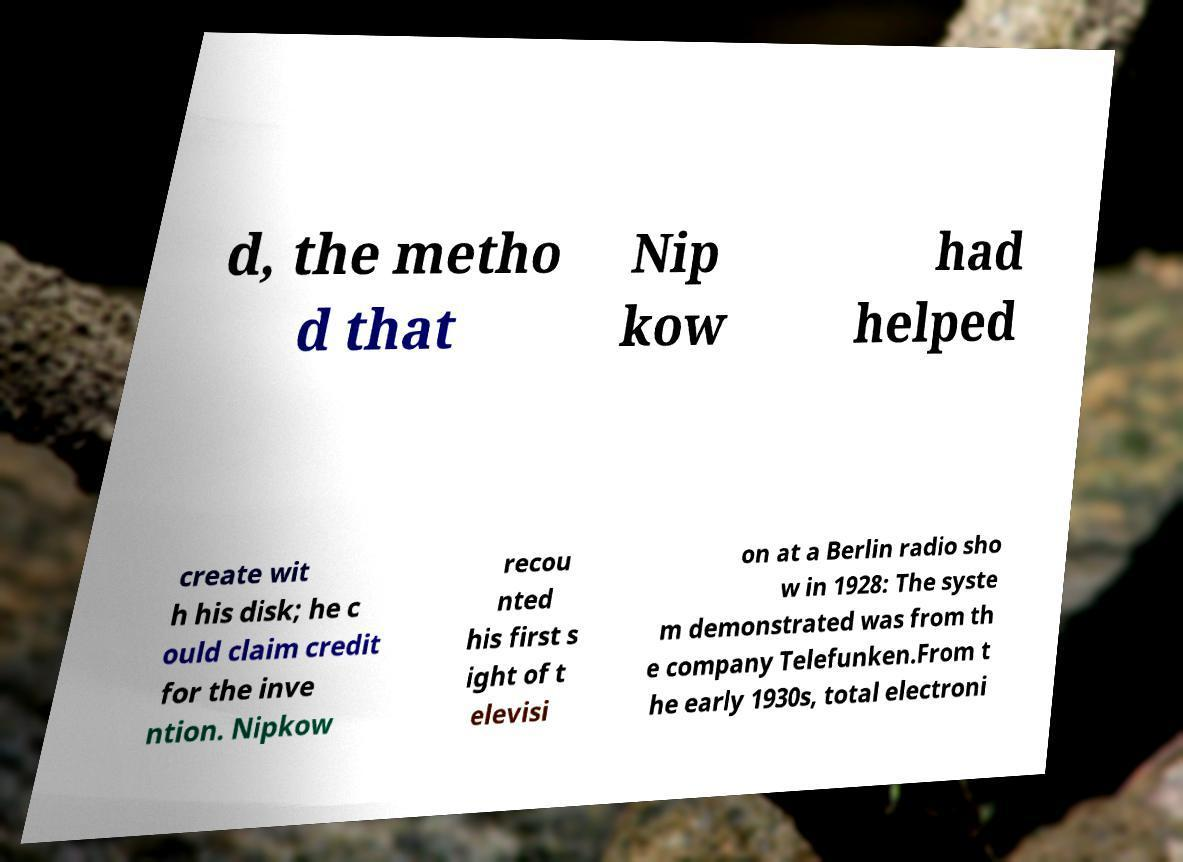There's text embedded in this image that I need extracted. Can you transcribe it verbatim? d, the metho d that Nip kow had helped create wit h his disk; he c ould claim credit for the inve ntion. Nipkow recou nted his first s ight of t elevisi on at a Berlin radio sho w in 1928: The syste m demonstrated was from th e company Telefunken.From t he early 1930s, total electroni 